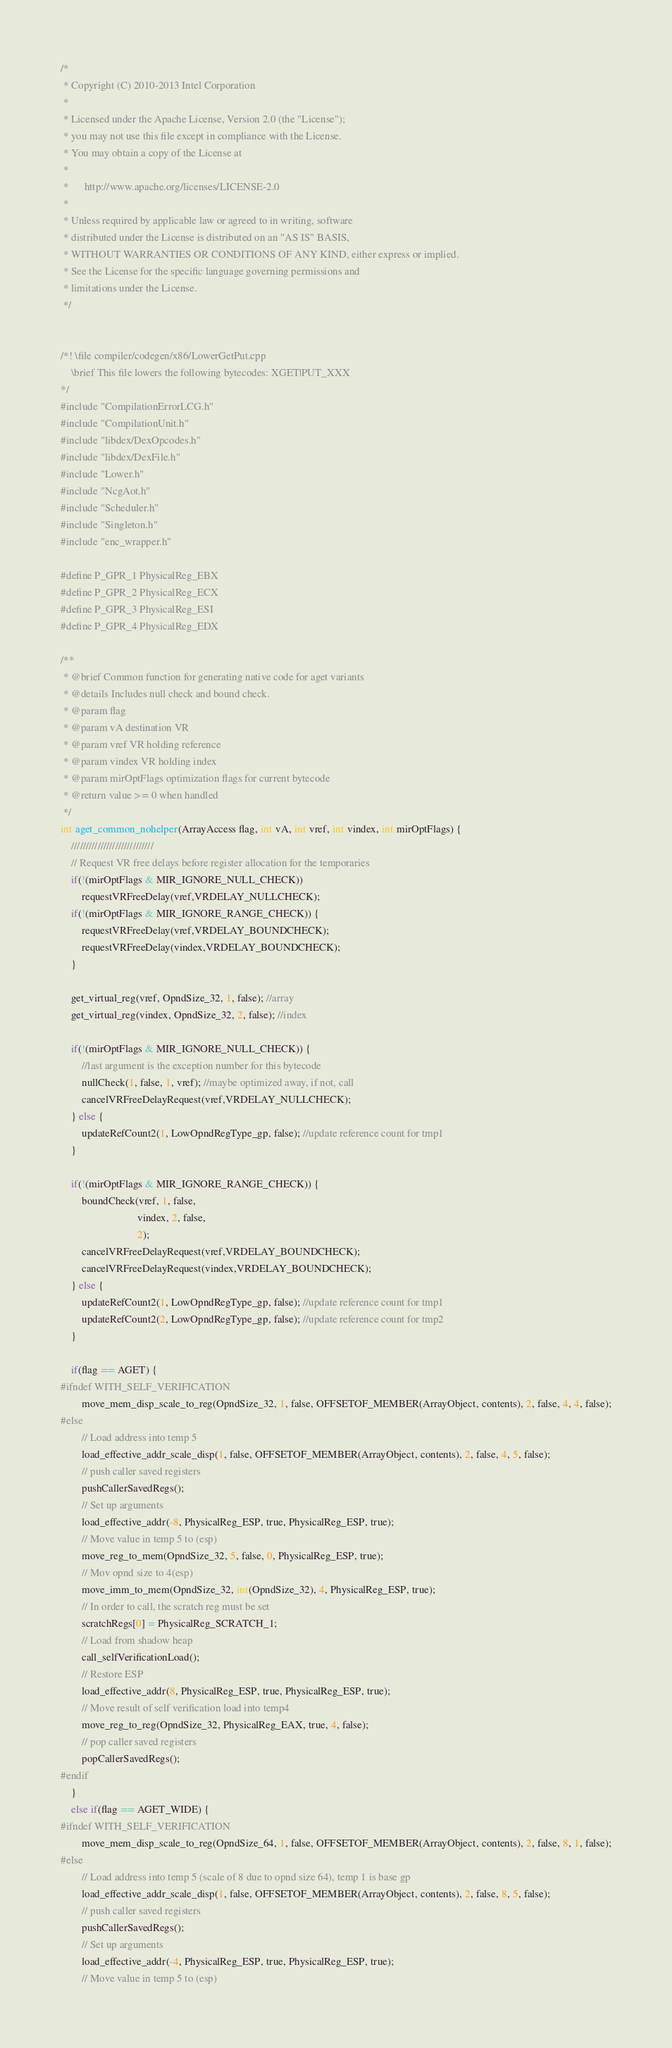Convert code to text. <code><loc_0><loc_0><loc_500><loc_500><_C++_>/*
 * Copyright (C) 2010-2013 Intel Corporation
 *
 * Licensed under the Apache License, Version 2.0 (the "License");
 * you may not use this file except in compliance with the License.
 * You may obtain a copy of the License at
 *
 *      http://www.apache.org/licenses/LICENSE-2.0
 *
 * Unless required by applicable law or agreed to in writing, software
 * distributed under the License is distributed on an "AS IS" BASIS,
 * WITHOUT WARRANTIES OR CONDITIONS OF ANY KIND, either express or implied.
 * See the License for the specific language governing permissions and
 * limitations under the License.
 */


/*! \file compiler/codegen/x86/LowerGetPut.cpp
    \brief This file lowers the following bytecodes: XGET|PUT_XXX
*/
#include "CompilationErrorLCG.h"
#include "CompilationUnit.h"
#include "libdex/DexOpcodes.h"
#include "libdex/DexFile.h"
#include "Lower.h"
#include "NcgAot.h"
#include "Scheduler.h"
#include "Singleton.h"
#include "enc_wrapper.h"

#define P_GPR_1 PhysicalReg_EBX
#define P_GPR_2 PhysicalReg_ECX
#define P_GPR_3 PhysicalReg_ESI
#define P_GPR_4 PhysicalReg_EDX

/**
 * @brief Common function for generating native code for aget variants
 * @details Includes null check and bound check.
 * @param flag
 * @param vA destination VR
 * @param vref VR holding reference
 * @param vindex VR holding index
 * @param mirOptFlags optimization flags for current bytecode
 * @return value >= 0 when handled
 */
int aget_common_nohelper(ArrayAccess flag, int vA, int vref, int vindex, int mirOptFlags) {
    ////////////////////////////
    // Request VR free delays before register allocation for the temporaries
    if(!(mirOptFlags & MIR_IGNORE_NULL_CHECK))
        requestVRFreeDelay(vref,VRDELAY_NULLCHECK);
    if(!(mirOptFlags & MIR_IGNORE_RANGE_CHECK)) {
        requestVRFreeDelay(vref,VRDELAY_BOUNDCHECK);
        requestVRFreeDelay(vindex,VRDELAY_BOUNDCHECK);
    }

    get_virtual_reg(vref, OpndSize_32, 1, false); //array
    get_virtual_reg(vindex, OpndSize_32, 2, false); //index

    if(!(mirOptFlags & MIR_IGNORE_NULL_CHECK)) {
        //last argument is the exception number for this bytecode
        nullCheck(1, false, 1, vref); //maybe optimized away, if not, call
        cancelVRFreeDelayRequest(vref,VRDELAY_NULLCHECK);
    } else {
        updateRefCount2(1, LowOpndRegType_gp, false); //update reference count for tmp1
    }

    if(!(mirOptFlags & MIR_IGNORE_RANGE_CHECK)) {
        boundCheck(vref, 1, false,
                             vindex, 2, false,
                             2);
        cancelVRFreeDelayRequest(vref,VRDELAY_BOUNDCHECK);
        cancelVRFreeDelayRequest(vindex,VRDELAY_BOUNDCHECK);
    } else {
        updateRefCount2(1, LowOpndRegType_gp, false); //update reference count for tmp1
        updateRefCount2(2, LowOpndRegType_gp, false); //update reference count for tmp2
    }

    if(flag == AGET) {
#ifndef WITH_SELF_VERIFICATION
        move_mem_disp_scale_to_reg(OpndSize_32, 1, false, OFFSETOF_MEMBER(ArrayObject, contents), 2, false, 4, 4, false);
#else
        // Load address into temp 5
        load_effective_addr_scale_disp(1, false, OFFSETOF_MEMBER(ArrayObject, contents), 2, false, 4, 5, false);
        // push caller saved registers
        pushCallerSavedRegs();
        // Set up arguments
        load_effective_addr(-8, PhysicalReg_ESP, true, PhysicalReg_ESP, true);
        // Move value in temp 5 to (esp)
        move_reg_to_mem(OpndSize_32, 5, false, 0, PhysicalReg_ESP, true);
        // Mov opnd size to 4(esp)
        move_imm_to_mem(OpndSize_32, int(OpndSize_32), 4, PhysicalReg_ESP, true);
        // In order to call, the scratch reg must be set
        scratchRegs[0] = PhysicalReg_SCRATCH_1;
        // Load from shadow heap
        call_selfVerificationLoad();
        // Restore ESP
        load_effective_addr(8, PhysicalReg_ESP, true, PhysicalReg_ESP, true);
        // Move result of self verification load into temp4
        move_reg_to_reg(OpndSize_32, PhysicalReg_EAX, true, 4, false);
        // pop caller saved registers
        popCallerSavedRegs();
#endif
    }
    else if(flag == AGET_WIDE) {
#ifndef WITH_SELF_VERIFICATION
        move_mem_disp_scale_to_reg(OpndSize_64, 1, false, OFFSETOF_MEMBER(ArrayObject, contents), 2, false, 8, 1, false);
#else
        // Load address into temp 5 (scale of 8 due to opnd size 64), temp 1 is base gp
        load_effective_addr_scale_disp(1, false, OFFSETOF_MEMBER(ArrayObject, contents), 2, false, 8, 5, false);
        // push caller saved registers
        pushCallerSavedRegs();
        // Set up arguments
        load_effective_addr(-4, PhysicalReg_ESP, true, PhysicalReg_ESP, true);
        // Move value in temp 5 to (esp)</code> 